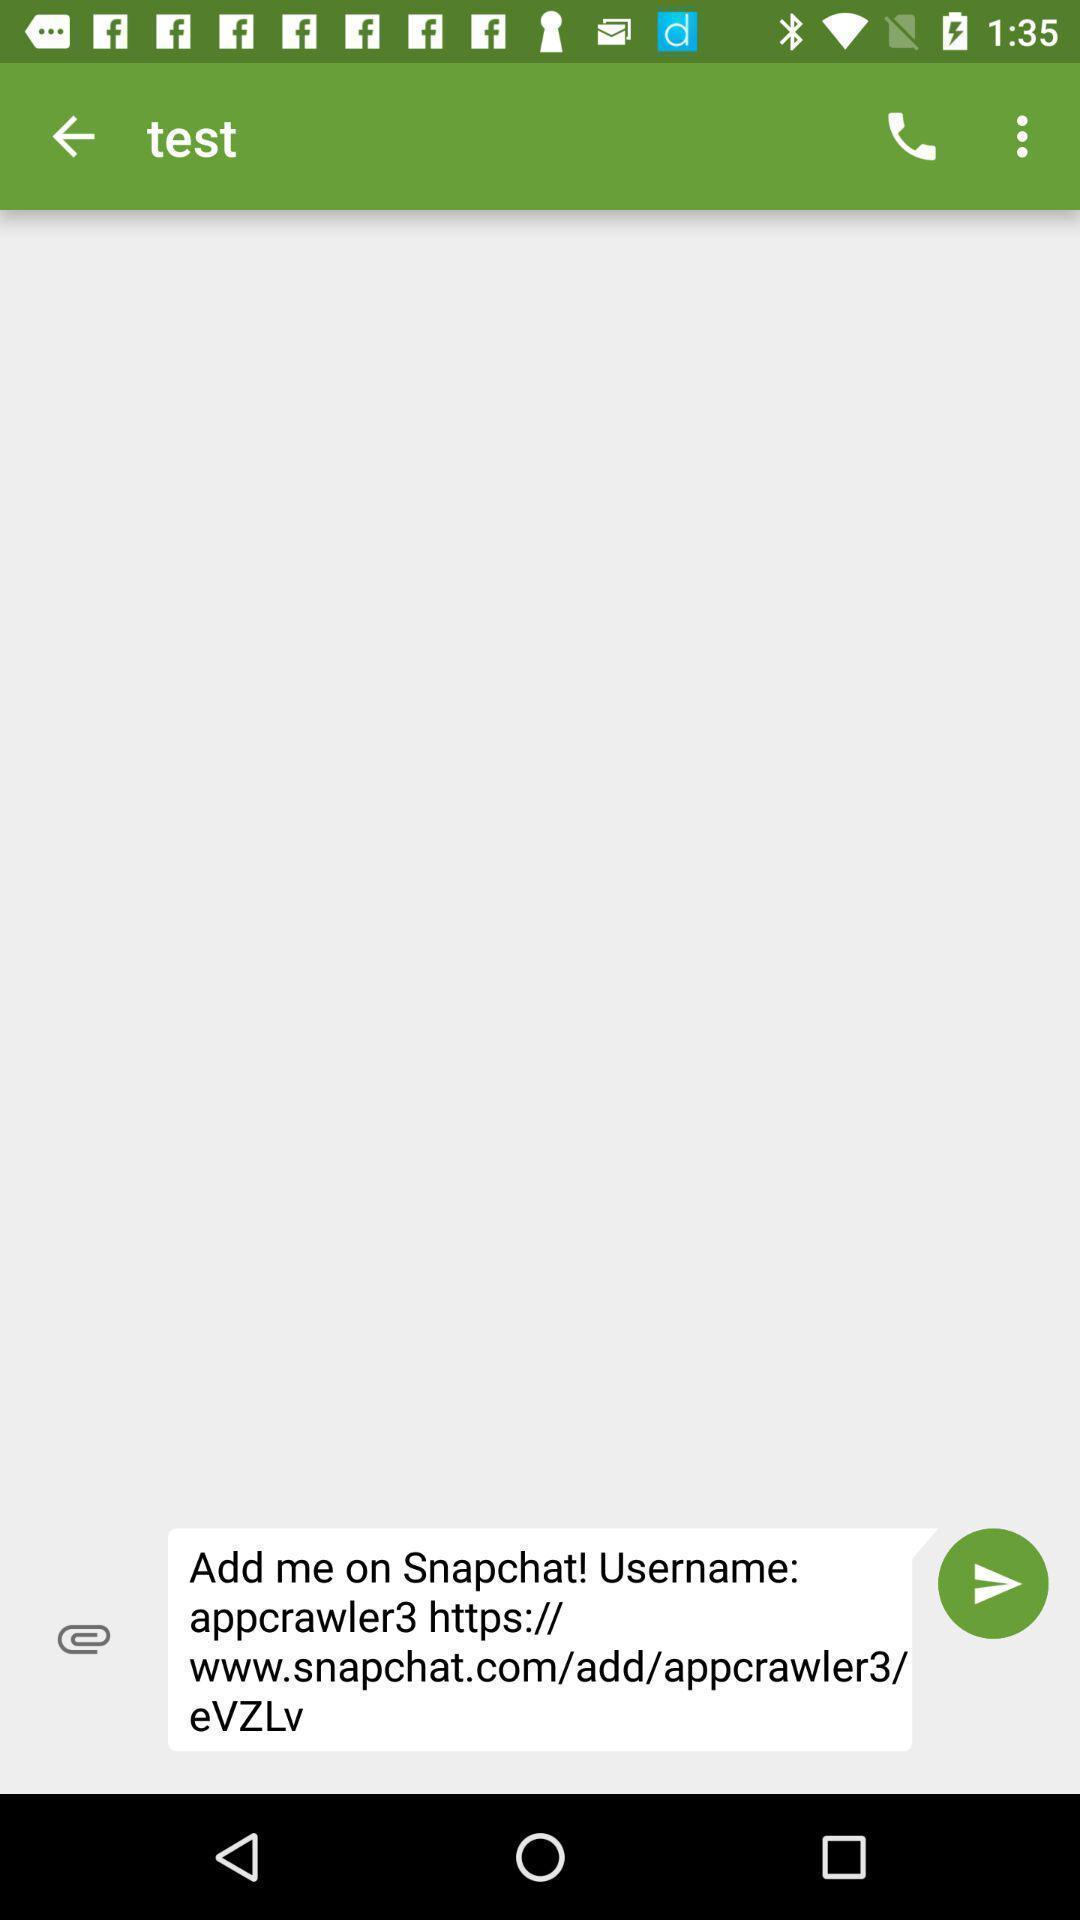Provide a textual representation of this image. Screen displaying contents in test page. 